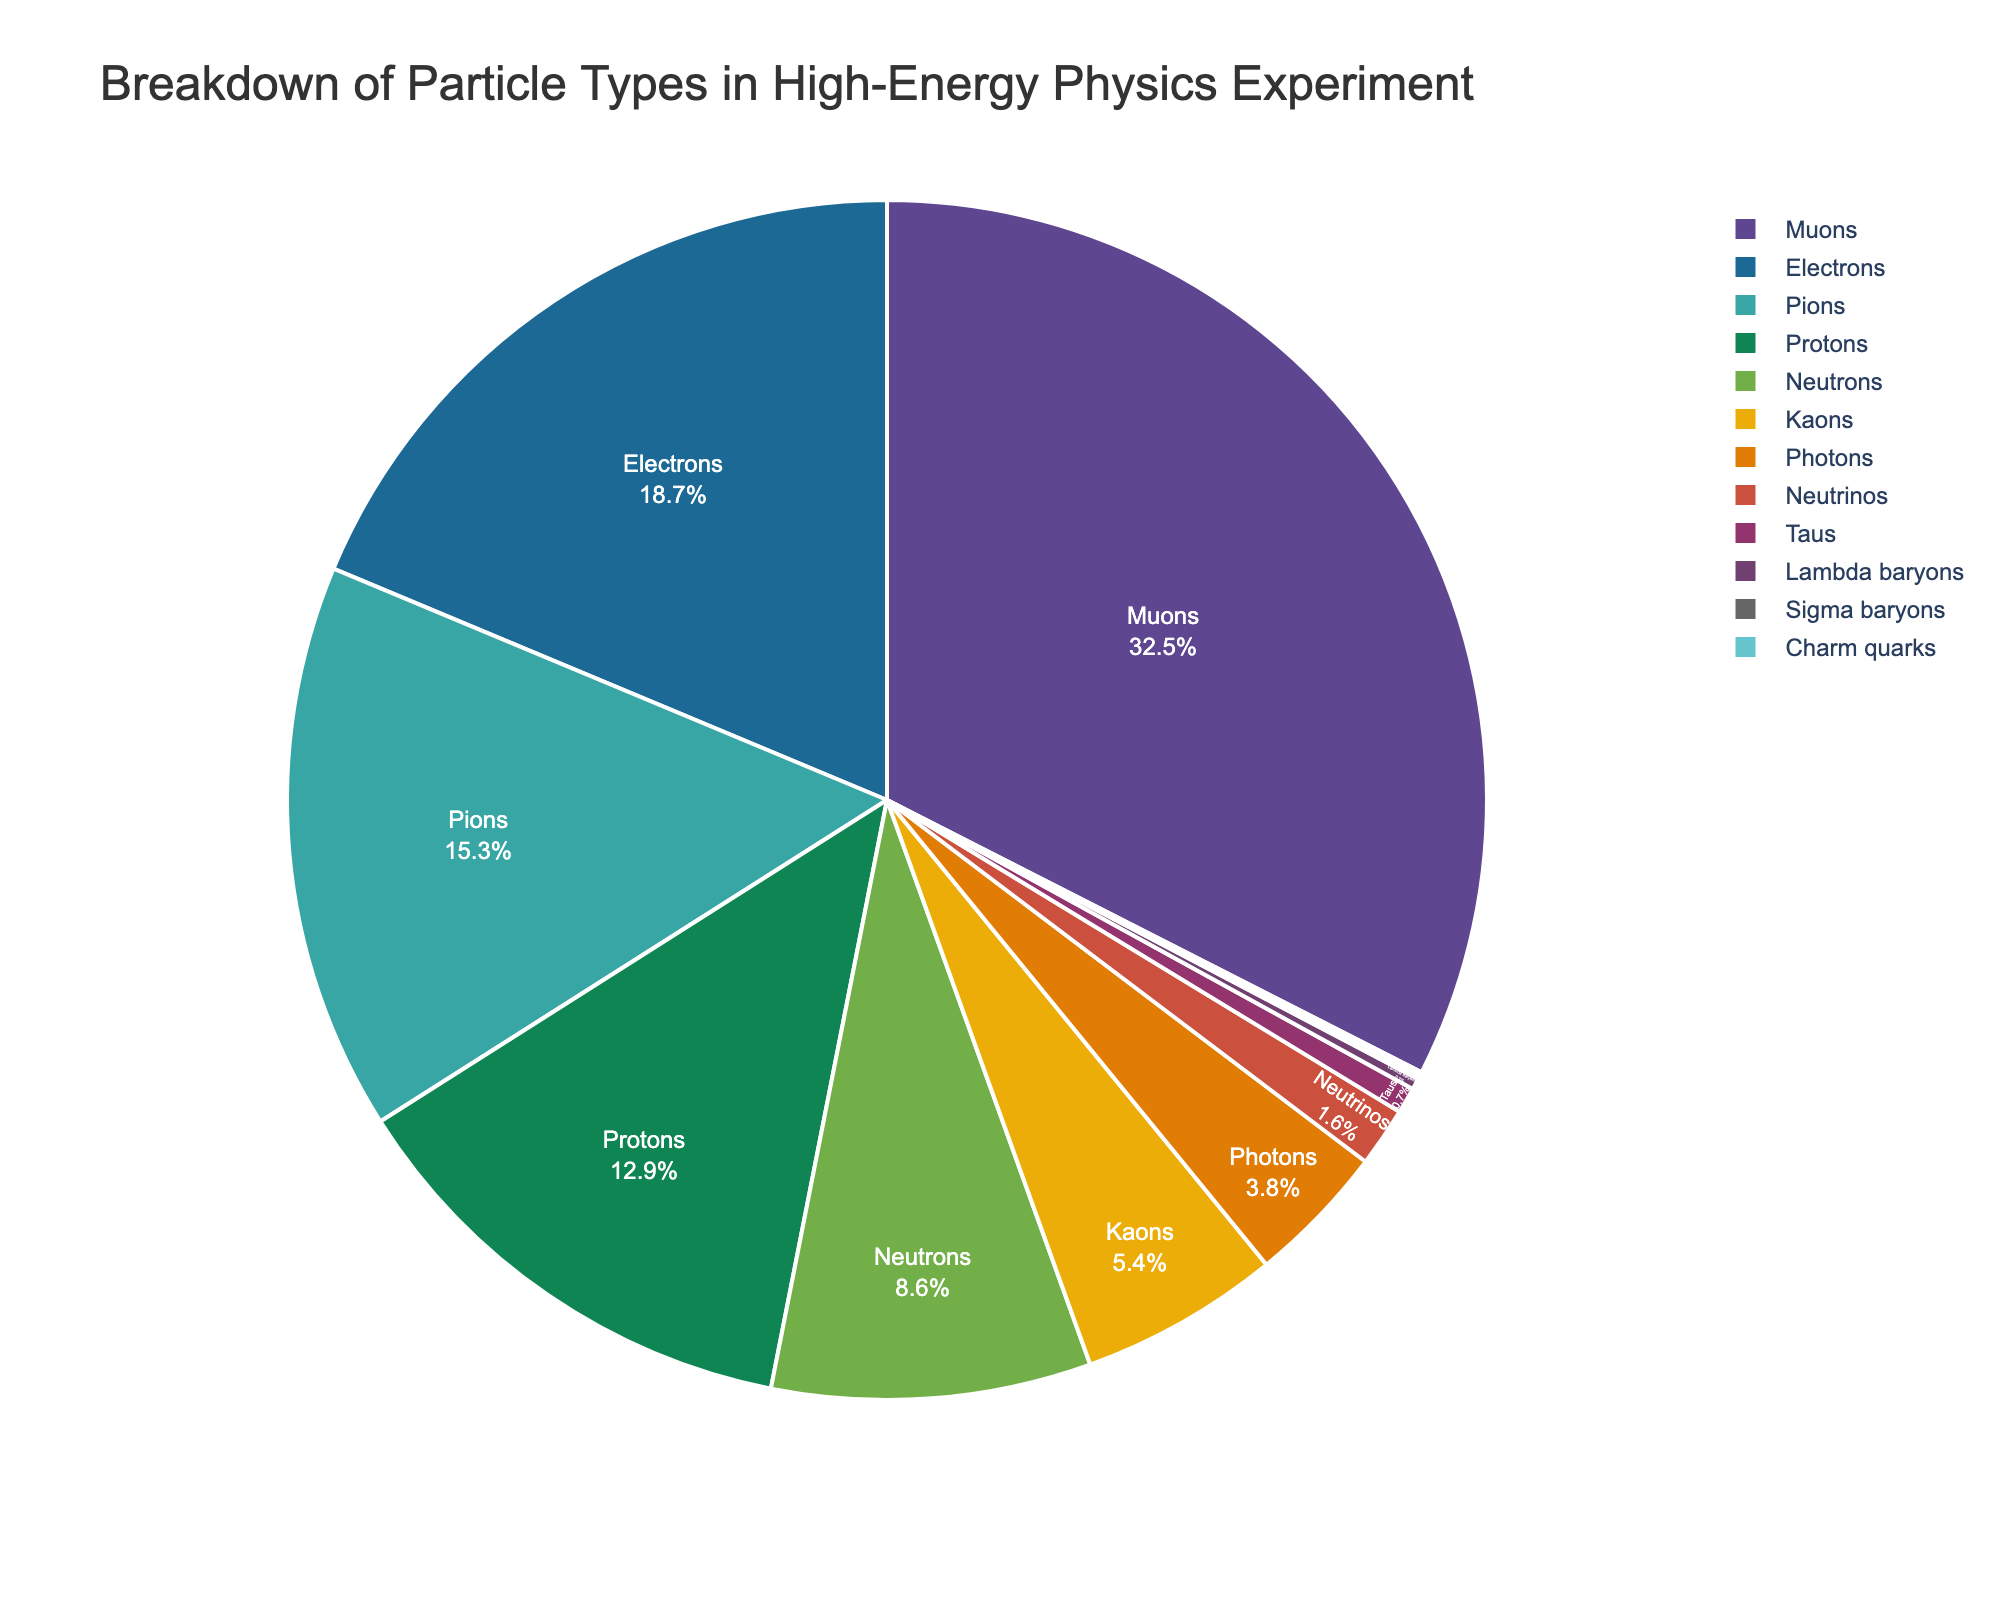What's the percentage of protons and neutrons combined? First, find the percentage of protons and neutrons from the pie chart. Then, sum the percentages: 12.9 (protons) + 8.6 (neutrons) = 21.5.
Answer: 21.5 Which particle type is the most commonly detected? Look for the segment of the pie chart with the highest percentage. The largest segment represents muons, with 32.5%.
Answer: Muons Are there more electrons or pions detected, and by how much? Compare the percentages of electrons (18.7%) and pions (15.3%). Subtract the smaller percentage from the larger: 18.7 - 15.3 = 3.4.
Answer: Electrons by 3.4% Which particle type has the smallest proportion in the experiment? Identify the smallest segment in the pie chart, which represents Sigma baryons with 0.1%.
Answer: Sigma baryons How do the percentages of electrons and muons compare? Compare the percentages of electrons (18.7%) and muons (32.5%). Muons have a higher percentage than electrons.
Answer: Muons have a higher percentage What is the combined percentage of electromagnetic particles (electrons and photons)? Add the percentages for electrons (18.7%) and photons (3.8%): 18.7 + 3.8 = 22.5.
Answer: 22.5 Which particle types together make up just over half (more than 50%) of the detected particles? Add the largest segments until the sum exceeds 50%. Muons (32.5%) and electrons (18.7%) together sum to 51.2%, which is just over half.
Answer: Muons and electrons How many particle types have a percentage below 5%? Count the segments with percentages below 5%: Kaons (5.4%) is just above, so these are Photons (3.8%), Neutrinos (1.6%), Taus (0.7%), Lambda baryons (0.3%), Sigma baryons (0.1%), and Charm quarks (0.1%).
Answer: 6 Which particle types are represented by more than one color in the custom color palette in the pie chart? Review the color palette (Prism + Pastel) used in the pie chart. No single particle type is represented by more than one color; each segment has a unique color.
Answer: None What proportion of detected particles are baryons (protons, neutrons, Lambda baryons, Sigma baryons)? Add the percentages for protons (12.9%), neutrons (8.6%), Lambda baryons (0.3%), and Sigma baryons (0.1%): 12.9 + 8.6 + 0.3 + 0.1 = 21.9.
Answer: 21.9 